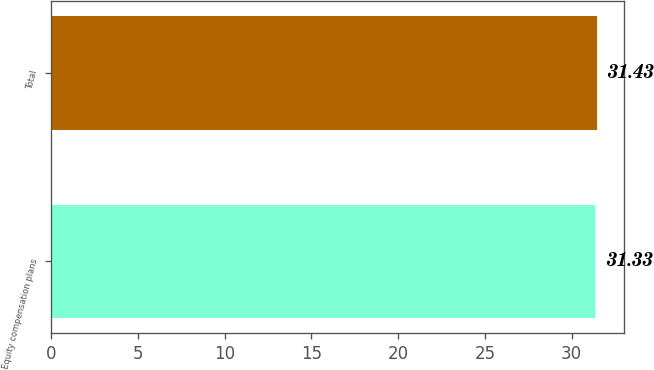<chart> <loc_0><loc_0><loc_500><loc_500><bar_chart><fcel>Equity compensation plans<fcel>Total<nl><fcel>31.33<fcel>31.43<nl></chart> 